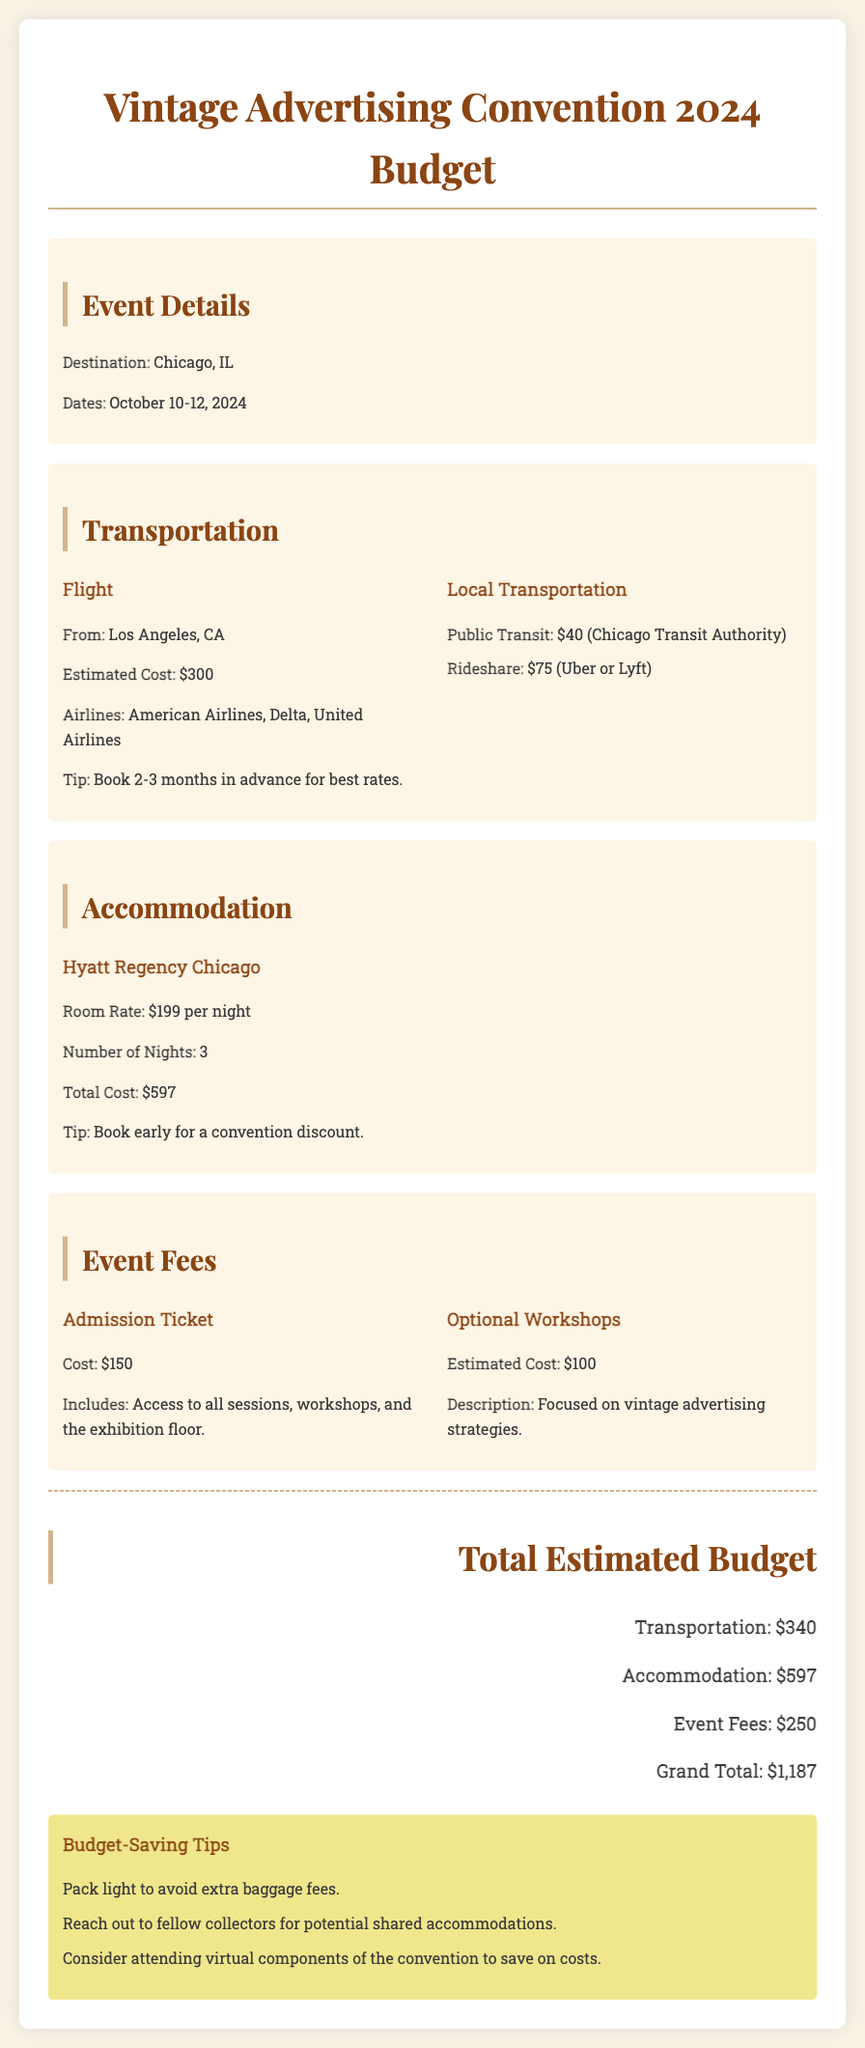What are the convention dates? The convention dates are October 10-12, 2024.
Answer: October 10-12, 2024 What is the estimated flight cost? The estimated flight cost is listed as $300.
Answer: $300 How much does accommodation per night cost? The accommodation room rate is given as $199 per night.
Answer: $199 What is the total accommodation cost for three nights? The total accommodation cost is calculated as $199 per night for 3 nights, which equals $597.
Answer: $597 What is the cost of the admission ticket? The document specifies the admission ticket cost as $150.
Answer: $150 What type of hotel is booked for the convention? The hotel mentioned for accommodation is the Hyatt Regency Chicago.
Answer: Hyatt Regency Chicago What is the total estimated budget for attending the convention? The grand total estimated budget is provided at the end of the document, which sums all costs.
Answer: $1,187 How much is allocated for local transportation? The budget indicates that local transportation is estimated at $75 for rideshare and $40 for public transit, totaling $115.
Answer: $115 What is a tip for booking flights? A tip provided in the document suggests to book 2-3 months in advance for best rates.
Answer: Book 2-3 months in advance 